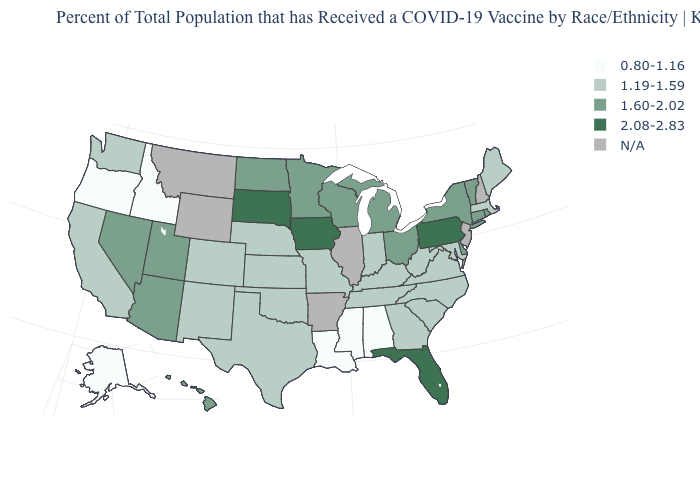Is the legend a continuous bar?
Be succinct. No. What is the value of South Dakota?
Write a very short answer. 2.08-2.83. Among the states that border Utah , which have the highest value?
Keep it brief. Arizona, Nevada. Name the states that have a value in the range N/A?
Concise answer only. Arkansas, Illinois, Montana, New Hampshire, New Jersey, Wyoming. What is the value of New Jersey?
Concise answer only. N/A. What is the highest value in the South ?
Be succinct. 2.08-2.83. Name the states that have a value in the range 1.19-1.59?
Short answer required. California, Colorado, Georgia, Indiana, Kansas, Kentucky, Maine, Maryland, Massachusetts, Missouri, Nebraska, New Mexico, North Carolina, Oklahoma, South Carolina, Tennessee, Texas, Virginia, Washington, West Virginia. What is the value of Idaho?
Give a very brief answer. 0.80-1.16. Which states have the highest value in the USA?
Short answer required. Florida, Iowa, Pennsylvania, South Dakota. Name the states that have a value in the range 2.08-2.83?
Short answer required. Florida, Iowa, Pennsylvania, South Dakota. What is the highest value in states that border Connecticut?
Concise answer only. 1.60-2.02. Does Arizona have the highest value in the West?
Write a very short answer. Yes. What is the highest value in states that border Arizona?
Give a very brief answer. 1.60-2.02. What is the value of California?
Concise answer only. 1.19-1.59. Does Nevada have the highest value in the West?
Answer briefly. Yes. 